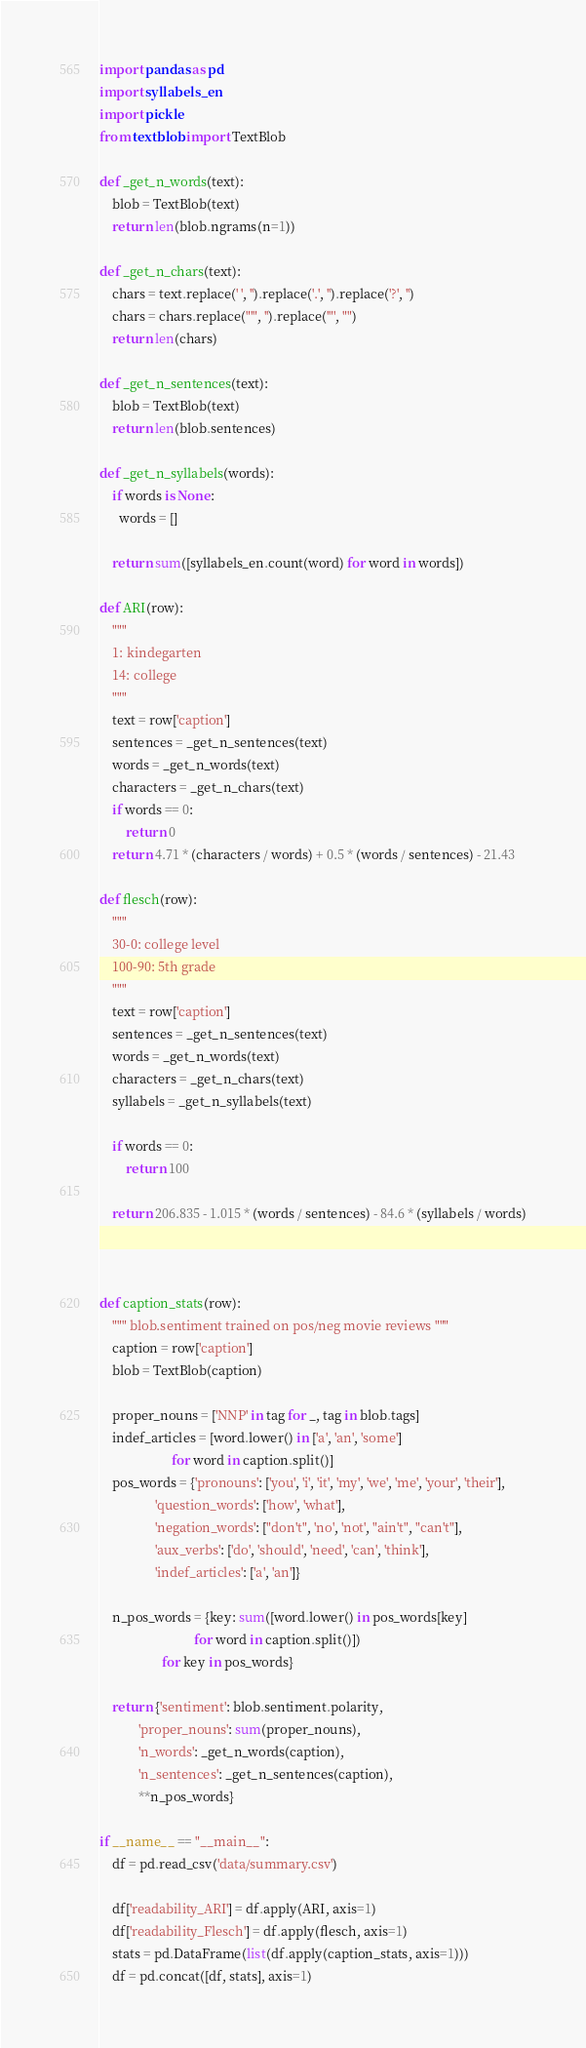<code> <loc_0><loc_0><loc_500><loc_500><_Python_>import pandas as pd
import syllabels_en
import pickle
from textblob import TextBlob

def _get_n_words(text):
    blob = TextBlob(text)
    return len(blob.ngrams(n=1))

def _get_n_chars(text):
    chars = text.replace(' ', '').replace('.', '').replace('?', '')
    chars = chars.replace("'", '').replace('"', "")
    return len(chars)

def _get_n_sentences(text):
    blob = TextBlob(text)
    return len(blob.sentences)

def _get_n_syllabels(words):
    if words is None:
      words = []

    return sum([syllabels_en.count(word) for word in words])

def ARI(row):
    """
    1: kindegarten
    14: college
    """
    text = row['caption']
    sentences = _get_n_sentences(text)
    words = _get_n_words(text)
    characters = _get_n_chars(text)
    if words == 0:
        return 0
    return 4.71 * (characters / words) + 0.5 * (words / sentences) - 21.43

def flesch(row):
    """
    30-0: college level
    100-90: 5th grade
    """
    text = row['caption']
    sentences = _get_n_sentences(text)
    words = _get_n_words(text)
    characters = _get_n_chars(text)
    syllabels = _get_n_syllabels(text)

    if words == 0:
        return 100

    return 206.835 - 1.015 * (words / sentences) - 84.6 * (syllabels / words)



def caption_stats(row):
    """ blob.sentiment trained on pos/neg movie reviews """
    caption = row['caption']
    blob = TextBlob(caption)

    proper_nouns = ['NNP' in tag for _, tag in blob.tags]
    indef_articles = [word.lower() in ['a', 'an', 'some']
                      for word in caption.split()]
    pos_words = {'pronouns': ['you', 'i', 'it', 'my', 'we', 'me', 'your', 'their'],
                 'question_words': ['how', 'what'],
                 'negation_words': ["don't", 'no', 'not', "ain't", "can't"],
                 'aux_verbs': ['do', 'should', 'need', 'can', 'think'],
                 'indef_articles': ['a', 'an']}

    n_pos_words = {key: sum([word.lower() in pos_words[key]
                             for word in caption.split()])
                   for key in pos_words}

    return {'sentiment': blob.sentiment.polarity,
            'proper_nouns': sum(proper_nouns),
            'n_words': _get_n_words(caption),
            'n_sentences': _get_n_sentences(caption),
            **n_pos_words}

if __name__ == "__main__":
    df = pd.read_csv('data/summary.csv')

    df['readability_ARI'] = df.apply(ARI, axis=1)
    df['readability_Flesch'] = df.apply(flesch, axis=1)
    stats = pd.DataFrame(list(df.apply(caption_stats, axis=1)))
    df = pd.concat([df, stats], axis=1)
</code> 